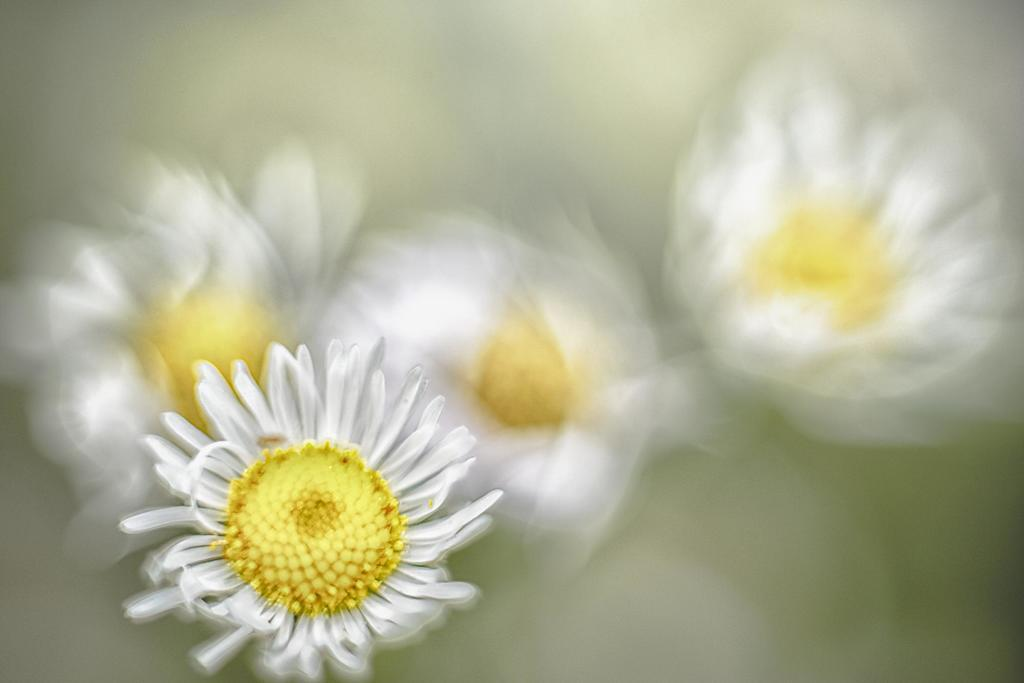What is the main subject of the image? The main subject of the image is flowers. Can you describe the flowers in the image? The flowers are in white and yellow colors. What type of cabbage is growing in the center of the image? There is no cabbage present in the image; it features flowers in white and yellow colors. 